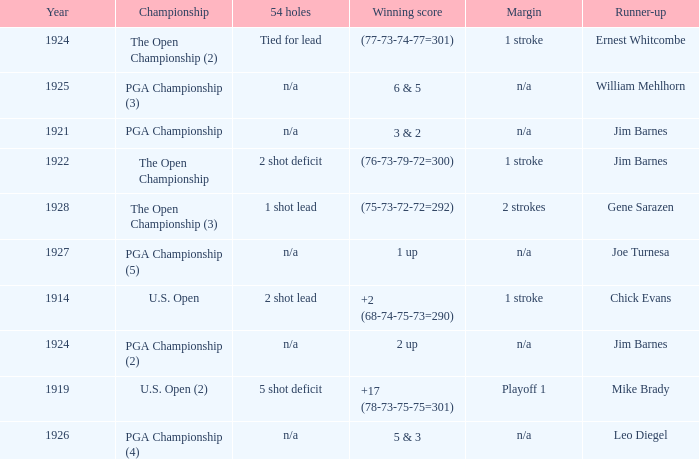HOW MANY YEARS WAS IT FOR THE SCORE (76-73-79-72=300)? 1.0. 